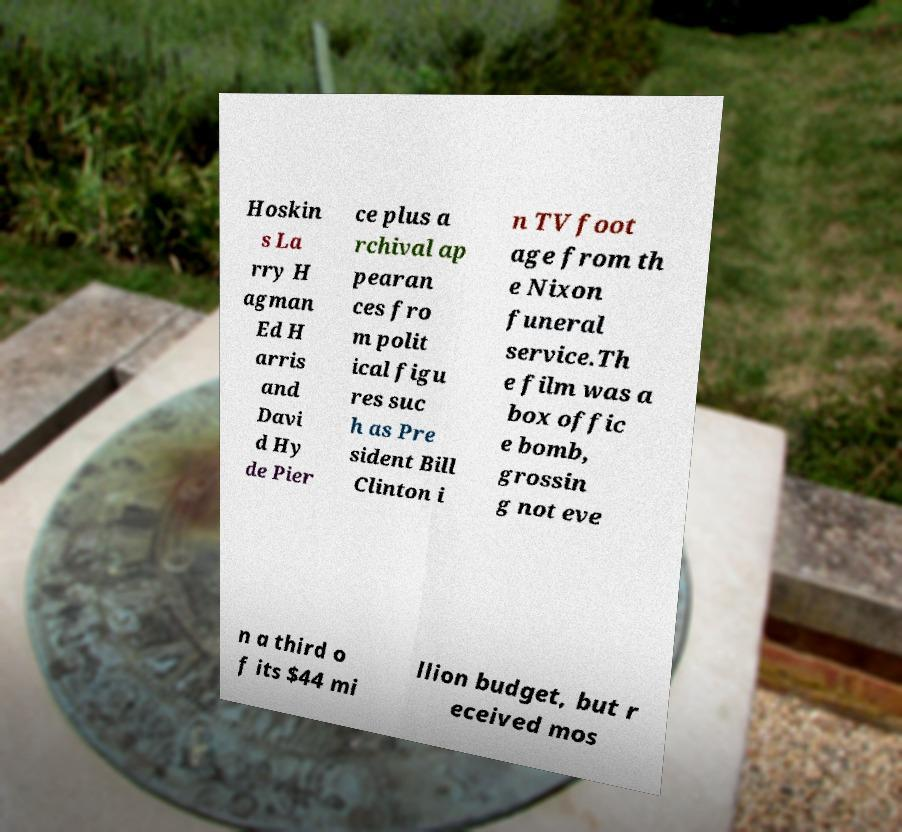Please read and relay the text visible in this image. What does it say? Hoskin s La rry H agman Ed H arris and Davi d Hy de Pier ce plus a rchival ap pearan ces fro m polit ical figu res suc h as Pre sident Bill Clinton i n TV foot age from th e Nixon funeral service.Th e film was a box offic e bomb, grossin g not eve n a third o f its $44 mi llion budget, but r eceived mos 